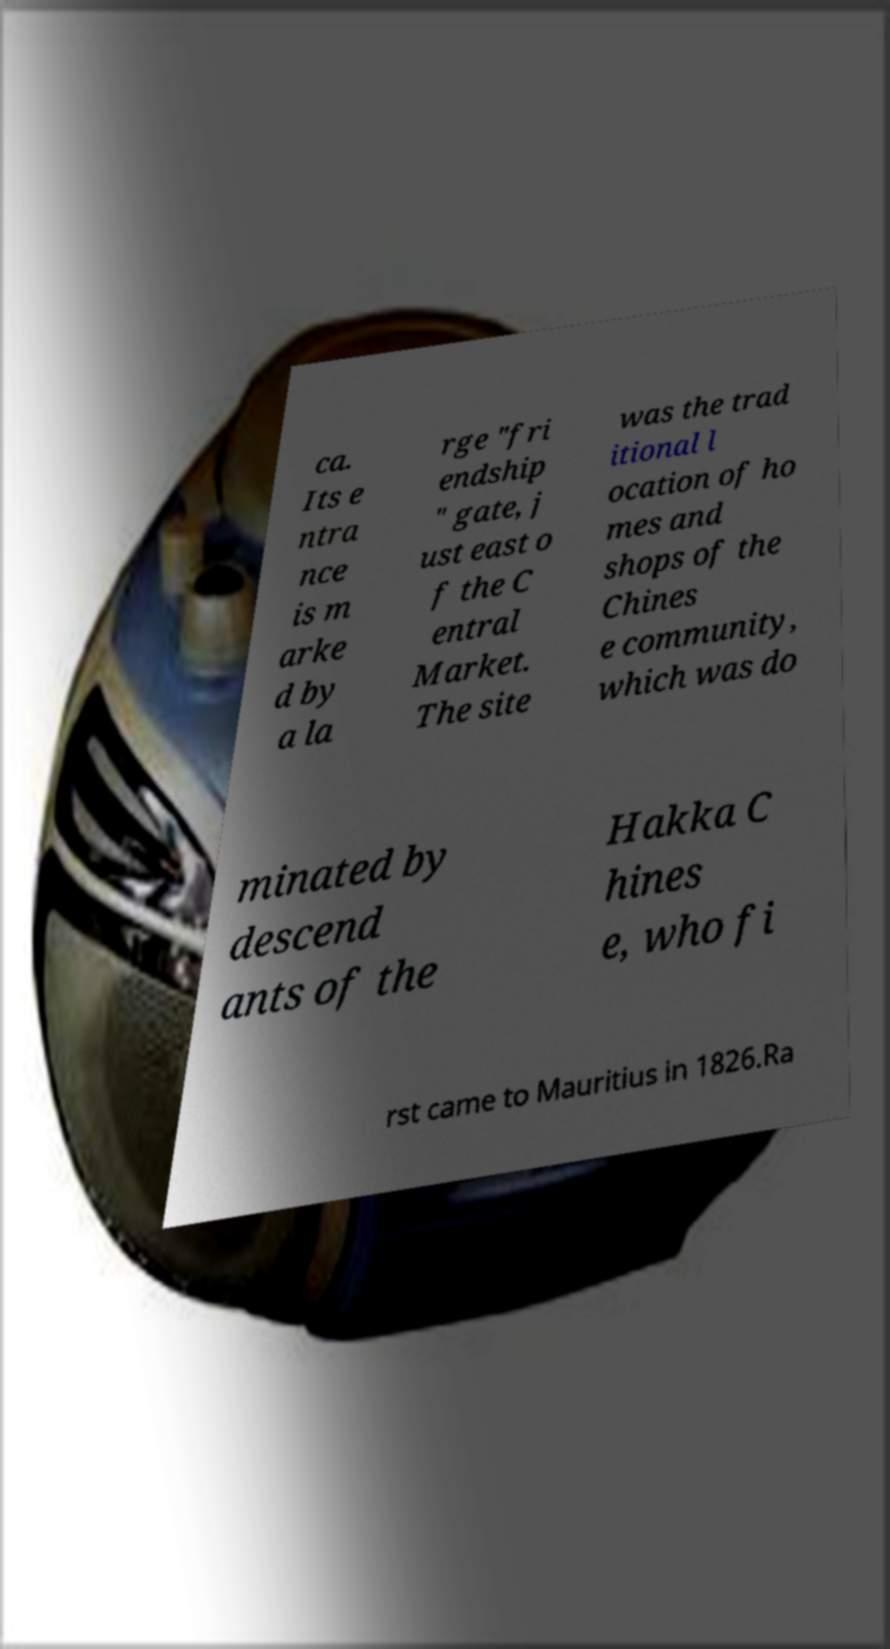Can you accurately transcribe the text from the provided image for me? ca. Its e ntra nce is m arke d by a la rge "fri endship " gate, j ust east o f the C entral Market. The site was the trad itional l ocation of ho mes and shops of the Chines e community, which was do minated by descend ants of the Hakka C hines e, who fi rst came to Mauritius in 1826.Ra 